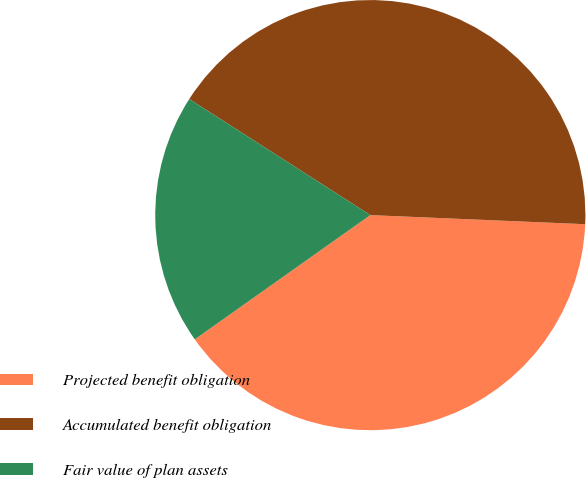Convert chart to OTSL. <chart><loc_0><loc_0><loc_500><loc_500><pie_chart><fcel>Projected benefit obligation<fcel>Accumulated benefit obligation<fcel>Fair value of plan assets<nl><fcel>39.52%<fcel>41.6%<fcel>18.88%<nl></chart> 